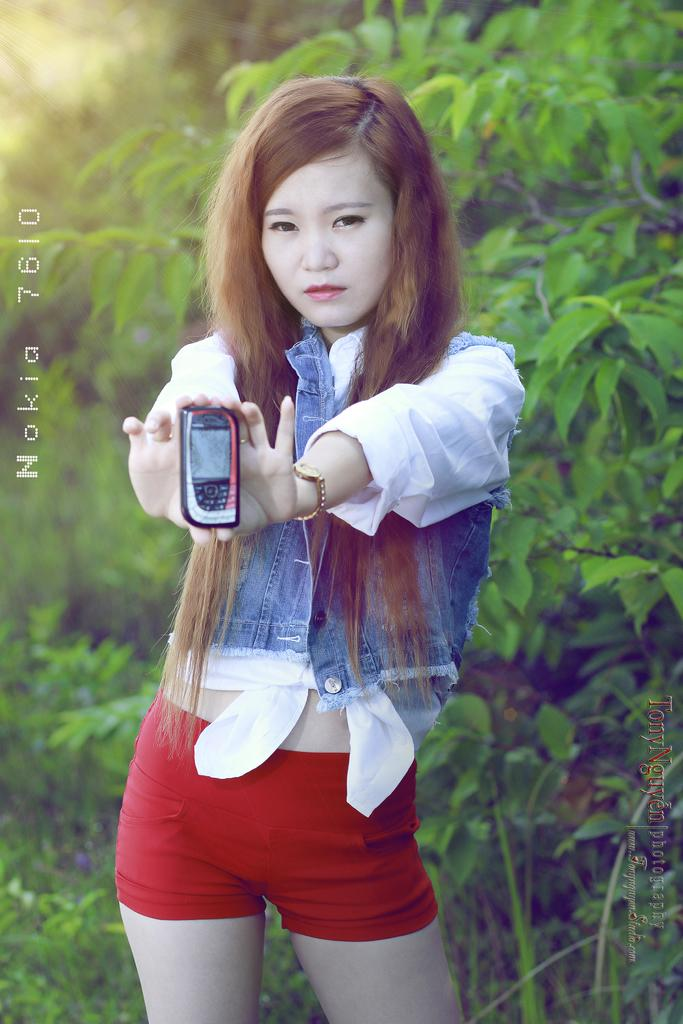Who is present in the image? There is a woman in the image. What is the woman doing in the image? The woman is standing in the image. What object is the woman holding in her hands? The woman is holding a mobile in her hands. What can be seen in the background of the image? There are trees visible in the background of the image. What type of beetle can be seen crawling on the woman's shoulder in the image? There is no beetle present on the woman's shoulder in the image. 